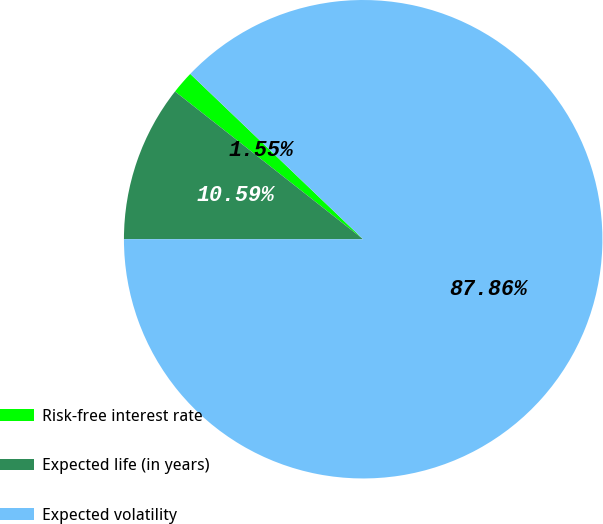<chart> <loc_0><loc_0><loc_500><loc_500><pie_chart><fcel>Risk-free interest rate<fcel>Expected life (in years)<fcel>Expected volatility<nl><fcel>1.55%<fcel>10.59%<fcel>87.86%<nl></chart> 